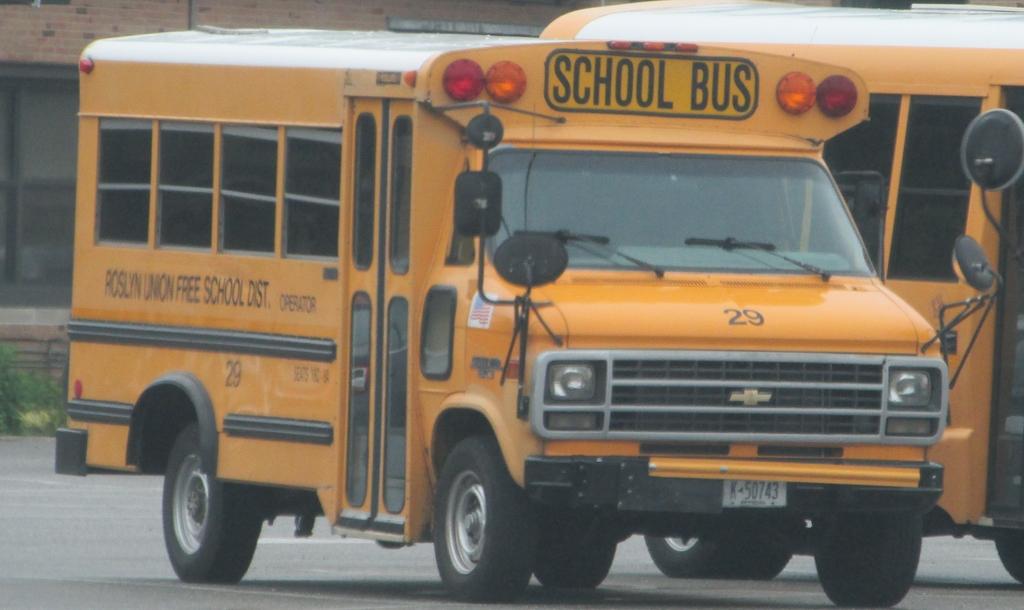What kind of bus is this?
Offer a very short reply. School bus. What number is the bus?
Provide a succinct answer. 29. 